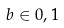Convert formula to latex. <formula><loc_0><loc_0><loc_500><loc_500>b \in { 0 , 1 }</formula> 